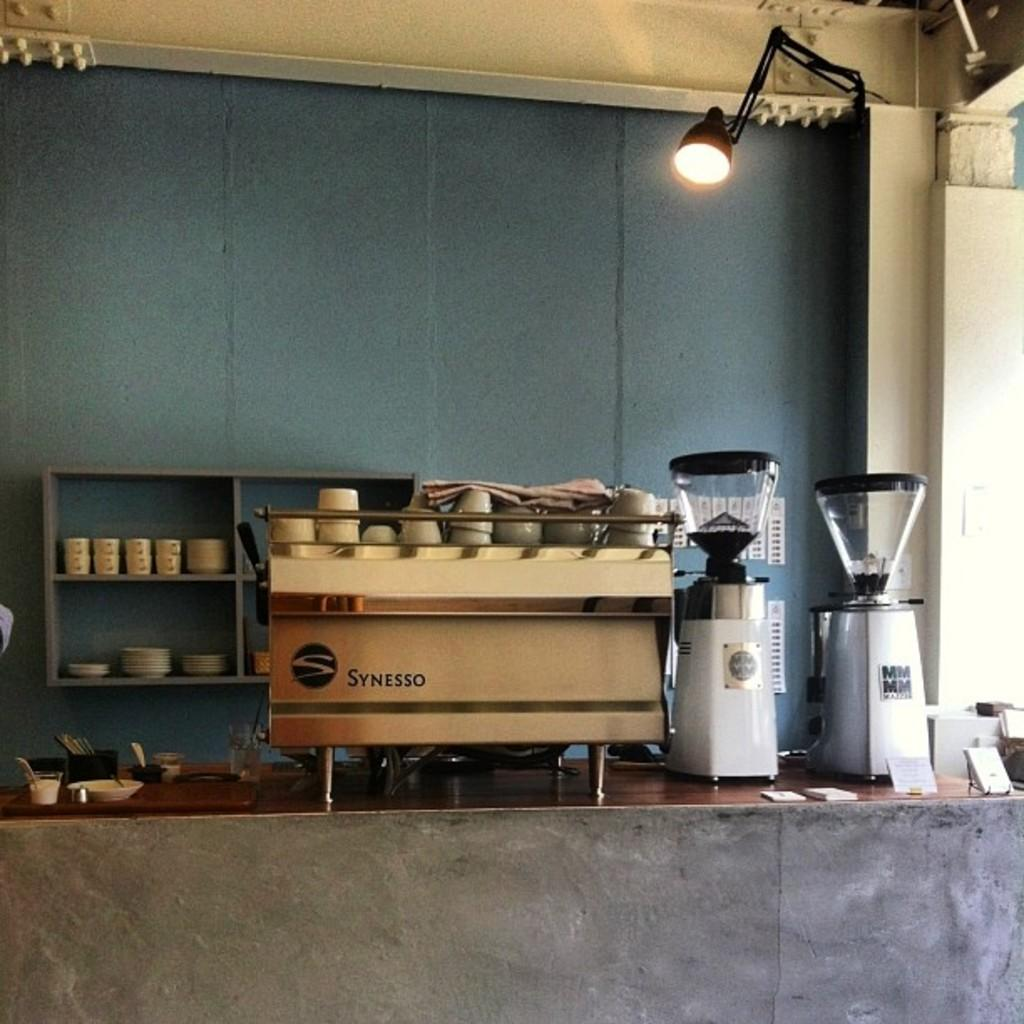Provide a one-sentence caption for the provided image. The coffee shop has a Synesso espresso machine with cups stacked on top. 